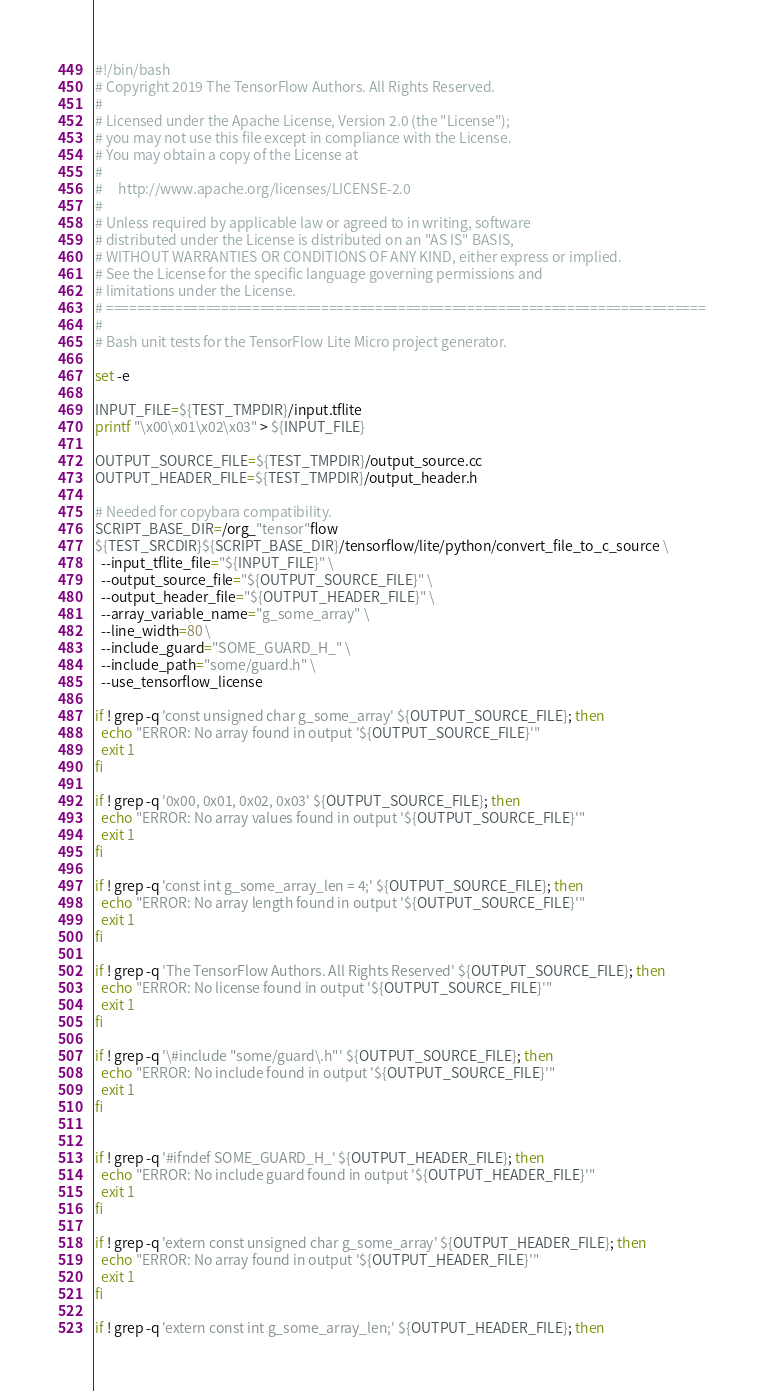<code> <loc_0><loc_0><loc_500><loc_500><_Bash_>#!/bin/bash
# Copyright 2019 The TensorFlow Authors. All Rights Reserved.
#
# Licensed under the Apache License, Version 2.0 (the "License");
# you may not use this file except in compliance with the License.
# You may obtain a copy of the License at
#
#     http://www.apache.org/licenses/LICENSE-2.0
#
# Unless required by applicable law or agreed to in writing, software
# distributed under the License is distributed on an "AS IS" BASIS,
# WITHOUT WARRANTIES OR CONDITIONS OF ANY KIND, either express or implied.
# See the License for the specific language governing permissions and
# limitations under the License.
# ==============================================================================
#
# Bash unit tests for the TensorFlow Lite Micro project generator.

set -e

INPUT_FILE=${TEST_TMPDIR}/input.tflite
printf "\x00\x01\x02\x03" > ${INPUT_FILE}

OUTPUT_SOURCE_FILE=${TEST_TMPDIR}/output_source.cc
OUTPUT_HEADER_FILE=${TEST_TMPDIR}/output_header.h

# Needed for copybara compatibility.
SCRIPT_BASE_DIR=/org_"tensor"flow
${TEST_SRCDIR}${SCRIPT_BASE_DIR}/tensorflow/lite/python/convert_file_to_c_source \
  --input_tflite_file="${INPUT_FILE}" \
  --output_source_file="${OUTPUT_SOURCE_FILE}" \
  --output_header_file="${OUTPUT_HEADER_FILE}" \
  --array_variable_name="g_some_array" \
  --line_width=80 \
  --include_guard="SOME_GUARD_H_" \
  --include_path="some/guard.h" \
  --use_tensorflow_license

if ! grep -q 'const unsigned char g_some_array' ${OUTPUT_SOURCE_FILE}; then
  echo "ERROR: No array found in output '${OUTPUT_SOURCE_FILE}'"
  exit 1
fi

if ! grep -q '0x00, 0x01, 0x02, 0x03' ${OUTPUT_SOURCE_FILE}; then
  echo "ERROR: No array values found in output '${OUTPUT_SOURCE_FILE}'"
  exit 1
fi

if ! grep -q 'const int g_some_array_len = 4;' ${OUTPUT_SOURCE_FILE}; then
  echo "ERROR: No array length found in output '${OUTPUT_SOURCE_FILE}'"
  exit 1
fi

if ! grep -q 'The TensorFlow Authors. All Rights Reserved' ${OUTPUT_SOURCE_FILE}; then
  echo "ERROR: No license found in output '${OUTPUT_SOURCE_FILE}'"
  exit 1
fi

if ! grep -q '\#include "some/guard\.h"' ${OUTPUT_SOURCE_FILE}; then
  echo "ERROR: No include found in output '${OUTPUT_SOURCE_FILE}'"
  exit 1
fi


if ! grep -q '#ifndef SOME_GUARD_H_' ${OUTPUT_HEADER_FILE}; then
  echo "ERROR: No include guard found in output '${OUTPUT_HEADER_FILE}'"
  exit 1
fi

if ! grep -q 'extern const unsigned char g_some_array' ${OUTPUT_HEADER_FILE}; then
  echo "ERROR: No array found in output '${OUTPUT_HEADER_FILE}'"
  exit 1
fi

if ! grep -q 'extern const int g_some_array_len;' ${OUTPUT_HEADER_FILE}; then</code> 